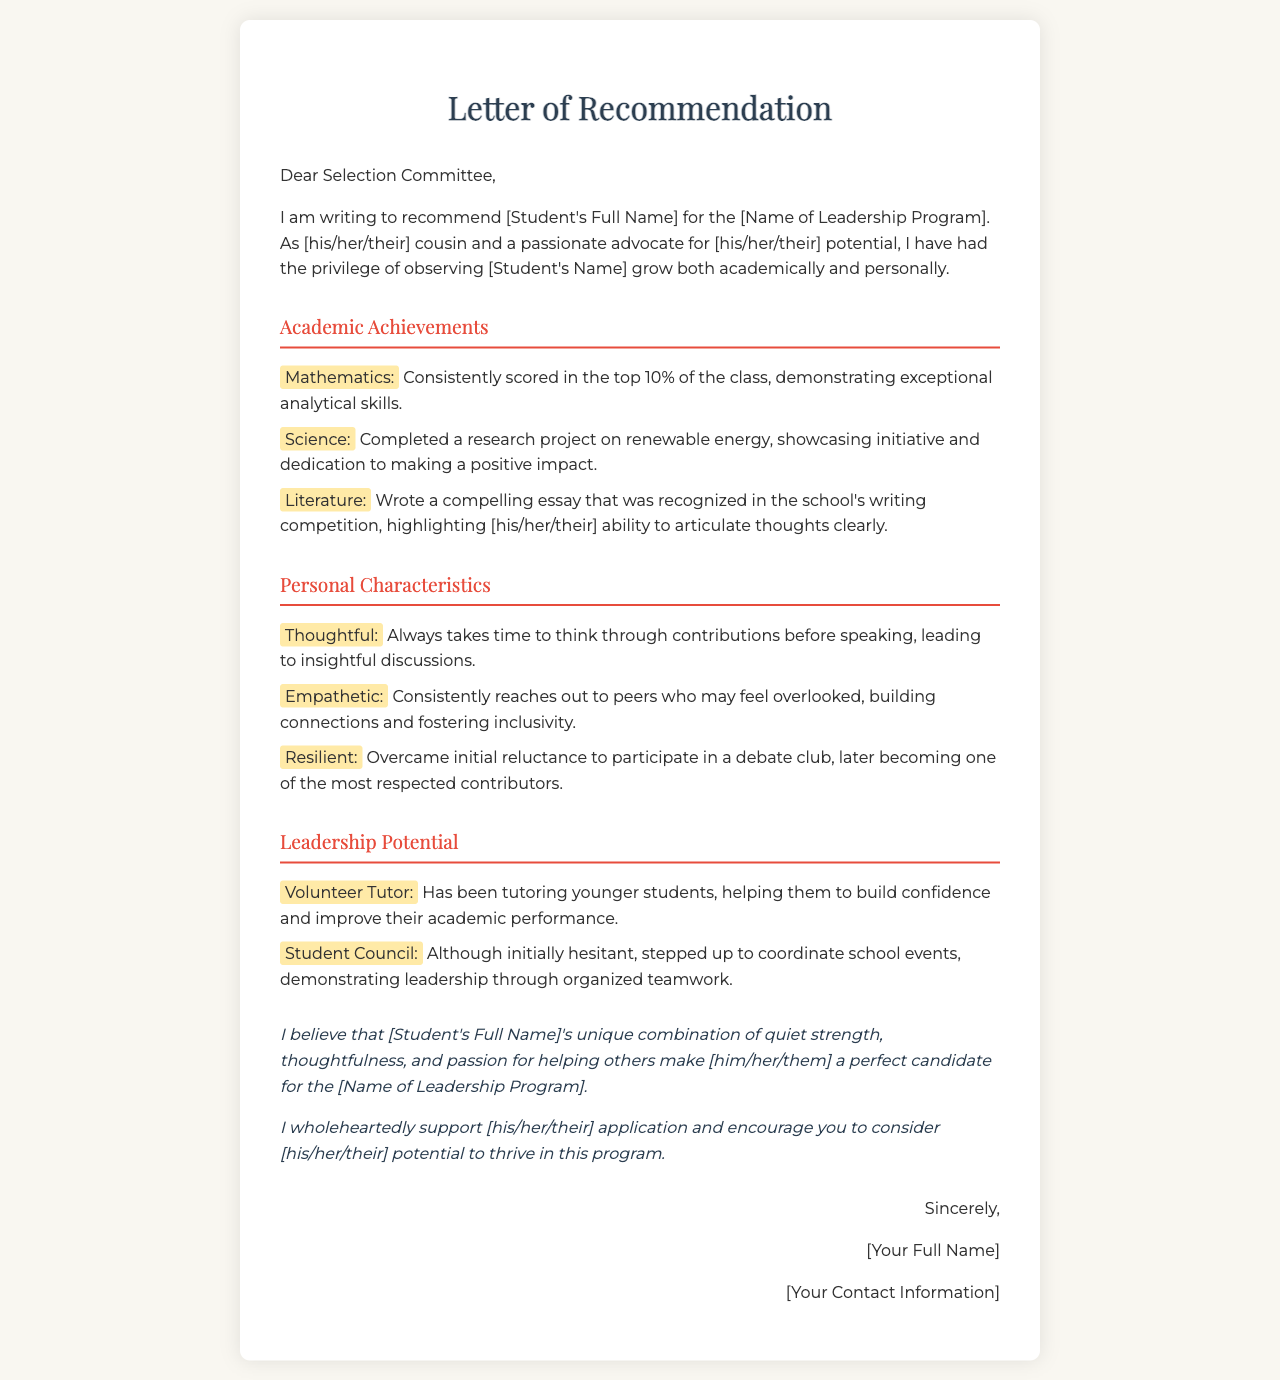What is the purpose of this letter? The letter is a recommendation for a student's application to a leadership program.
Answer: recommendation for a student's application to a leadership program Who is the writer of the letter? The letter is written by the student's cousin.
Answer: the student's cousin What is one academic achievement mentioned? The letter highlights a specific achievement in academia that exemplifies the student's skills.
Answer: completed a research project on renewable energy What quality is the student praised for in the personal characteristics section? The letter cites a specific trait that reflects the student's character.
Answer: empathetic What role did the student take in the Student Council? The letter describes the student's involvement in a particular council activity.
Answer: coordinate school events How does the writer describe the student's participation in debate? This question addresses the student's growth in a specific area.
Answer: became one of the most respected contributors What type of volunteer work has the student done? The letter notes a specific type of volunteer activity the student is involved in.
Answer: tutoring younger students What is emphasized about the student's potential? The letter conveys a particular sentiment regarding the student's future opportunities.
Answer: unique combination of quiet strength, thoughtfulness, and passion for helping others 